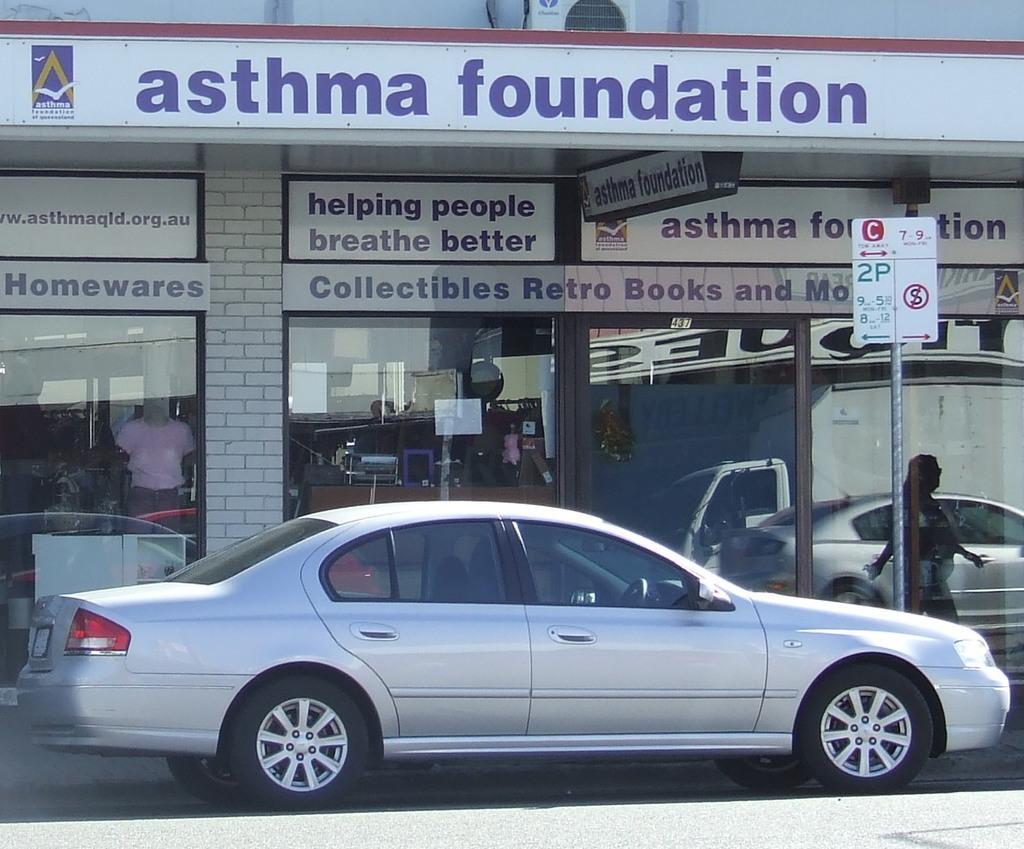Can you describe this image briefly? In this image we can see building, car, road and sign board. 